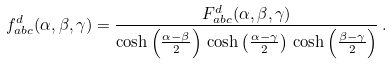<formula> <loc_0><loc_0><loc_500><loc_500>f ^ { d } _ { a b c } ( \alpha , \beta , \gamma ) = \frac { F ^ { d } _ { a b c } ( \alpha , \beta , \gamma ) } { \cosh \left ( \frac { \alpha - \beta } { 2 } \right ) \, \cosh \left ( \frac { \alpha - \gamma } { 2 } \right ) \, \cosh \left ( \frac { \beta - \gamma } { 2 } \right ) } \, .</formula> 